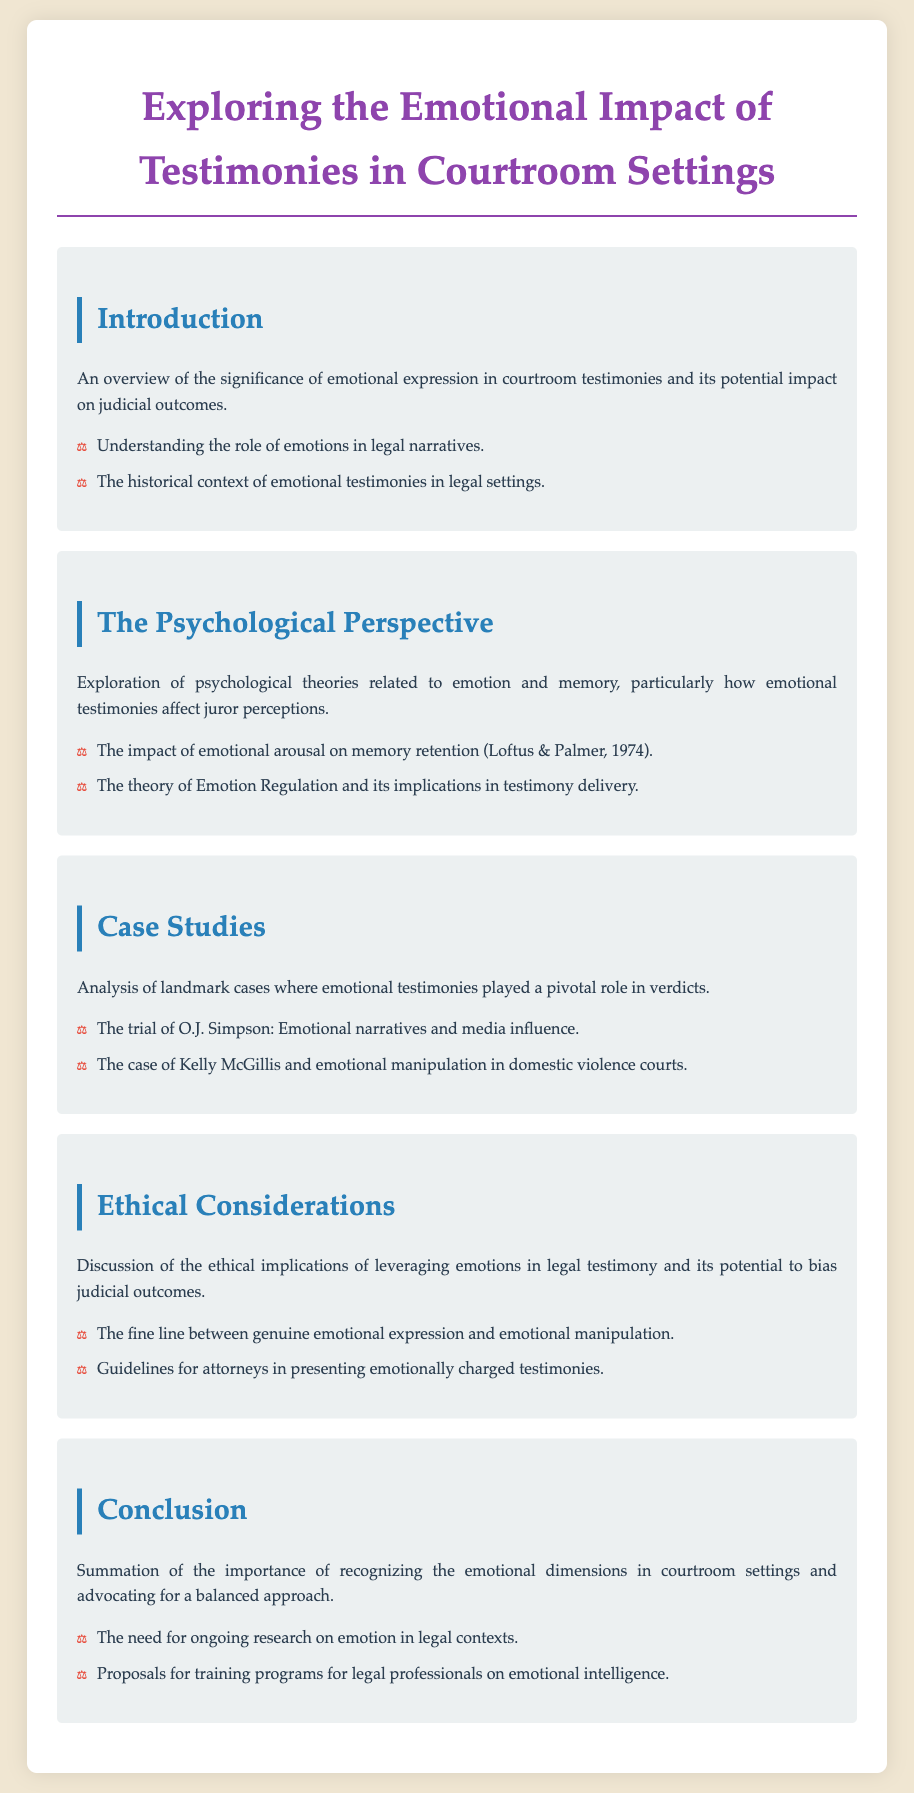What is the title of the document? The title presents the main topic of the agenda concerning the emotional aspects of testimonies in courtrooms.
Answer: Exploring the Emotional Impact of Testimonies in Courtroom Settings What historical context is mentioned? The introduction indicates there is a historical context related to emotional testimonies in legal settings.
Answer: The historical context of emotional testimonies in legal settings Who conducted notable research referenced in the psychological perspective? The section on the psychological perspective references researchers who studied the impact of emotional arousal on memory.
Answer: Loftus & Palmer What is a key ethical concern discussed? The document highlights ethical implications regarding the authenticity of emotional expressions in legal testimonies.
Answer: The fine line between genuine emotional expression and emotional manipulation Name one landmark case analyzed in the case studies section. The case studies section provides specific examples of trials where emotional testimonies influenced the verdicts.
Answer: The trial of O.J. Simpson What is proposed for legal professionals at the end of the document? The conclusion offers suggestions for improving legal practice concerning emotional intelligence.
Answer: Training programs for legal professionals on emotional intelligence 